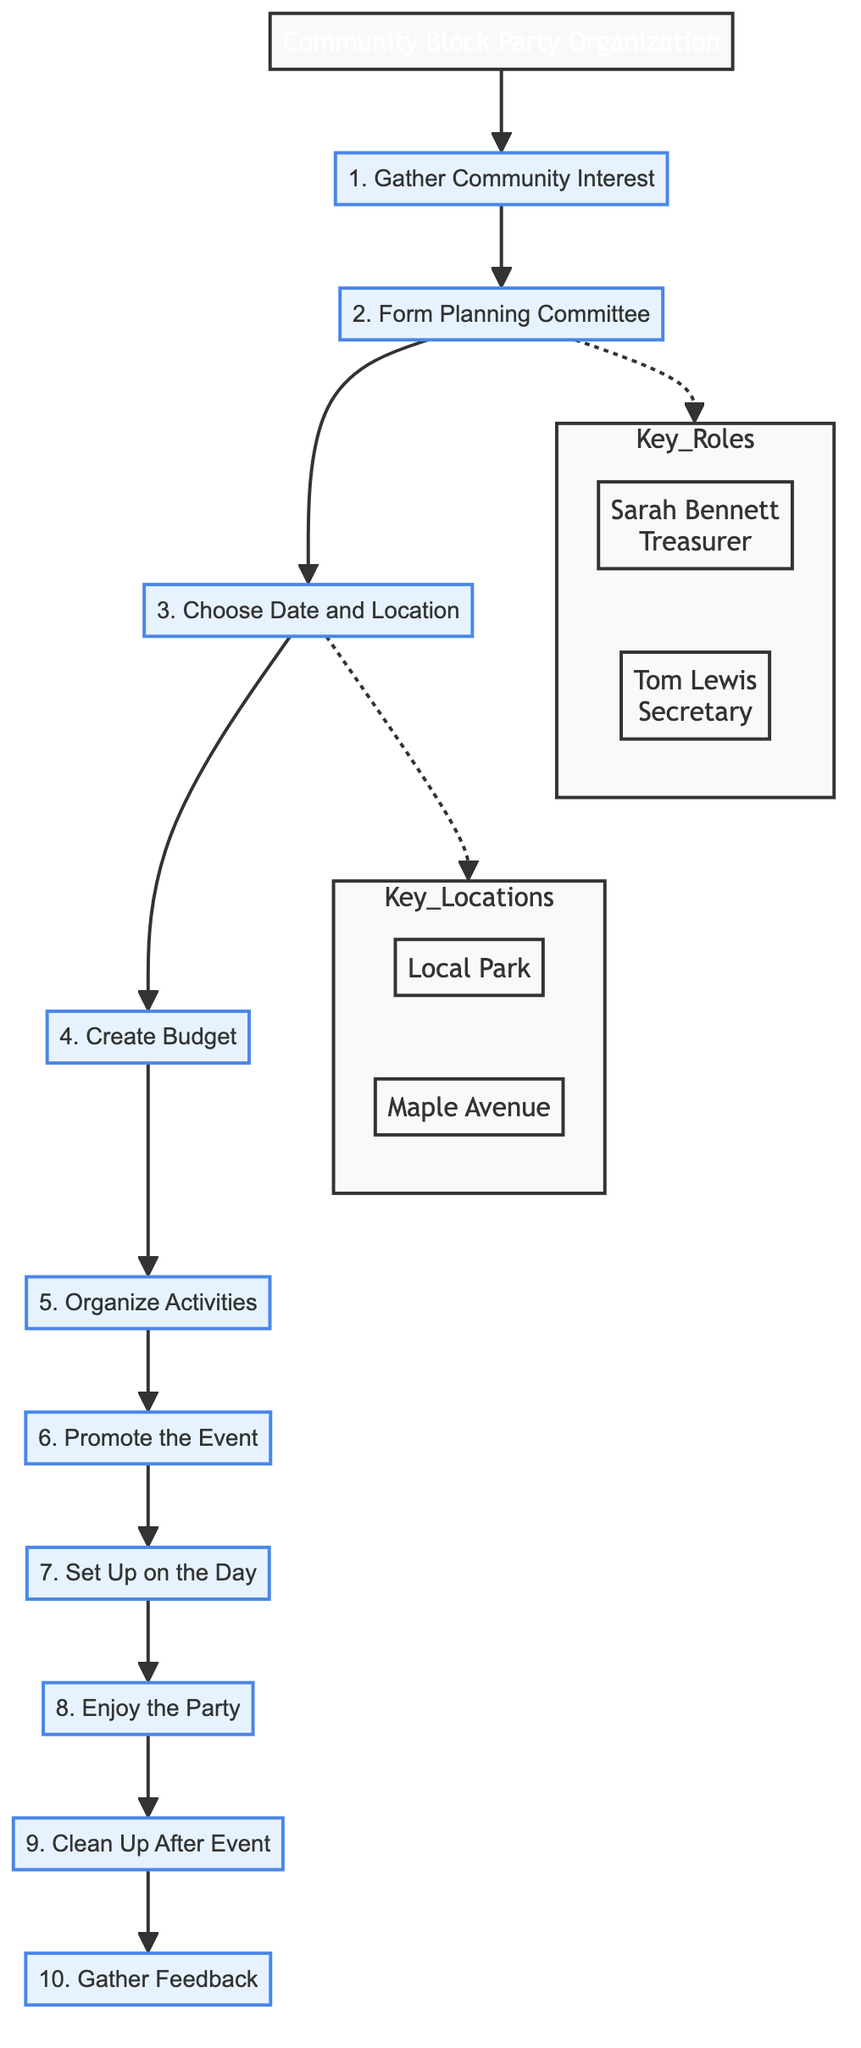What is the first step in organizing the event? The diagram starts with the first node labeled "1. Gather Community Interest" which indicates the initial step in the process.
Answer: Gather Community Interest Which role is assigned to Sarah Bennett? According to the diagram, Sarah Bennett is identified with the role of "Treasurer" as represented in the "Key Roles" subgraph connected to the second step.
Answer: Treasurer How many total steps are there in the flow chart? By counting each numbered step in the main flow, there are ten distinct steps outlined in the diagram.
Answer: 10 What is the location mentioned for the event? The diagram indicates two options in the "Key Locations" subgraph: "Local Park" and "Maple Avenue," which are associated with the third step.
Answer: Local Park, Maple Avenue Which step comes after "Set Up on the Day"? The flow of the diagram shows that "Enjoy the Party" is the immediate next step that follows the "Set Up on the Day" step in the sequence.
Answer: Enjoy the Party What is the purpose of gathering feedback? The final step, "Gather Feedback," serves the purpose of requesting input from community members to enhance future events, according to the diagram's last node description.
Answer: Improve future events In what way are Tom Lewis's duties described? The diagram presents Tom Lewis's role in the "Key Roles" subgraph, specifying that he serves as the "Secretary" tied to the "Form a Planning Committee" step.
Answer: Secretary Which activities are planned for the community block party? The "Organize Activities" step describes planning for games, music, and a potluck lunch as part of the event, highlighting the activities intended for enjoyment.
Answer: Games, music, potluck lunch 